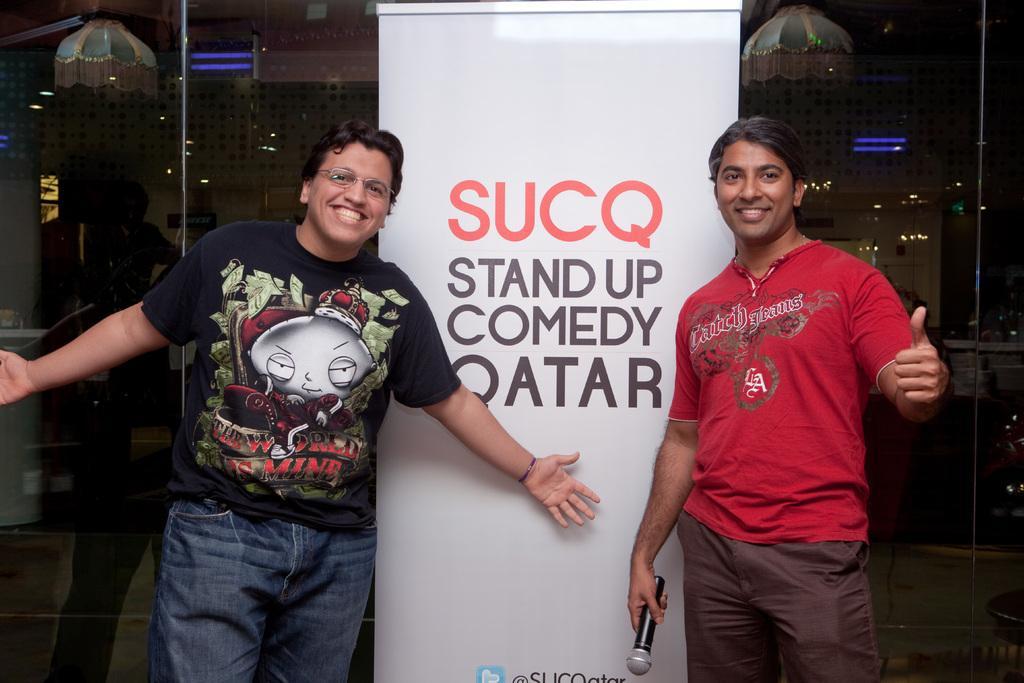How would you summarize this image in a sentence or two? In this image we can see two people standing and smiling. The man standing on the right is holding a mic. In the center there is a banner. In the background there is a glass. 